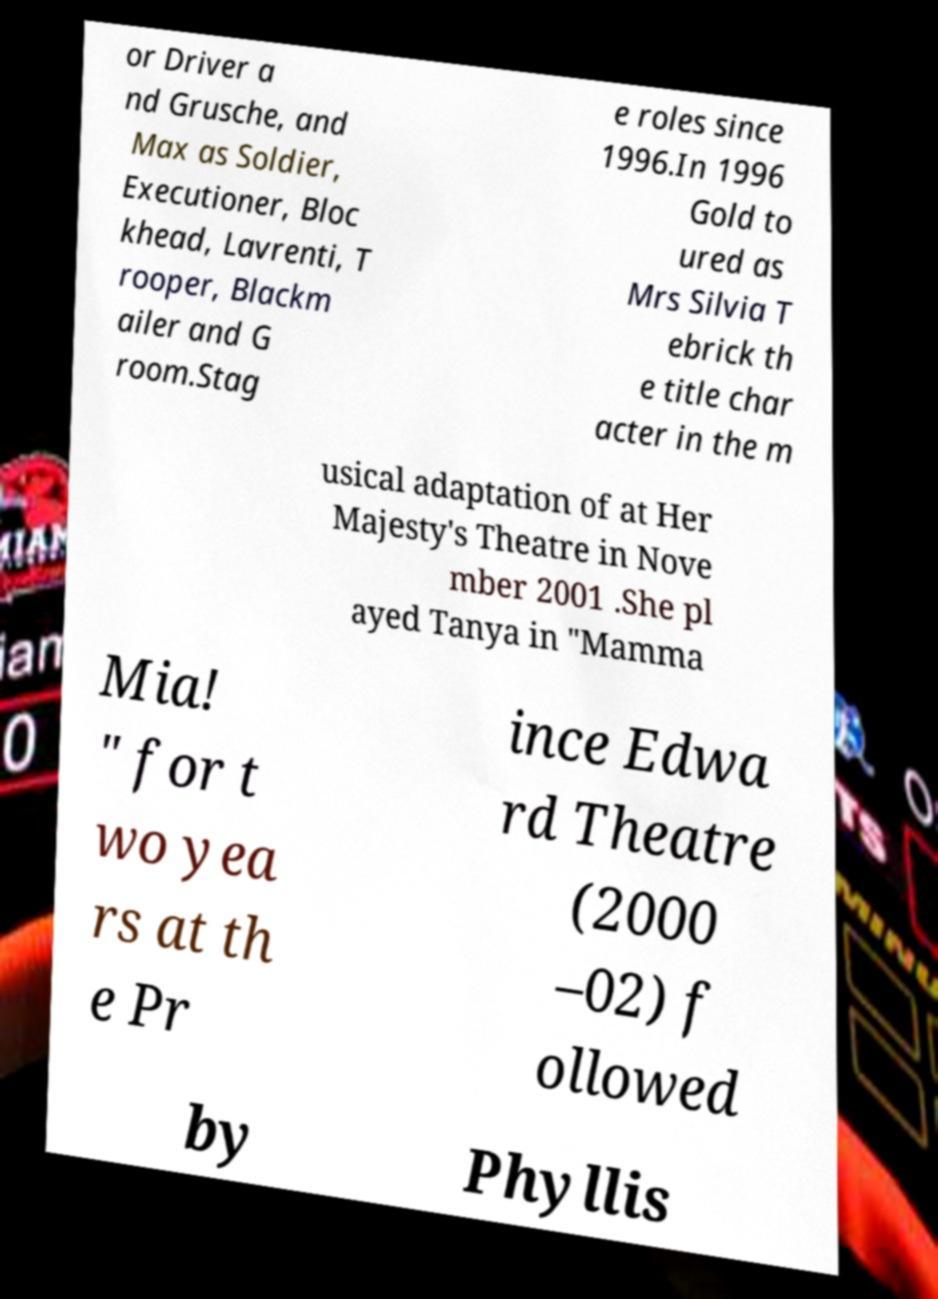There's text embedded in this image that I need extracted. Can you transcribe it verbatim? or Driver a nd Grusche, and Max as Soldier, Executioner, Bloc khead, Lavrenti, T rooper, Blackm ailer and G room.Stag e roles since 1996.In 1996 Gold to ured as Mrs Silvia T ebrick th e title char acter in the m usical adaptation of at Her Majesty's Theatre in Nove mber 2001 .She pl ayed Tanya in "Mamma Mia! " for t wo yea rs at th e Pr ince Edwa rd Theatre (2000 –02) f ollowed by Phyllis 